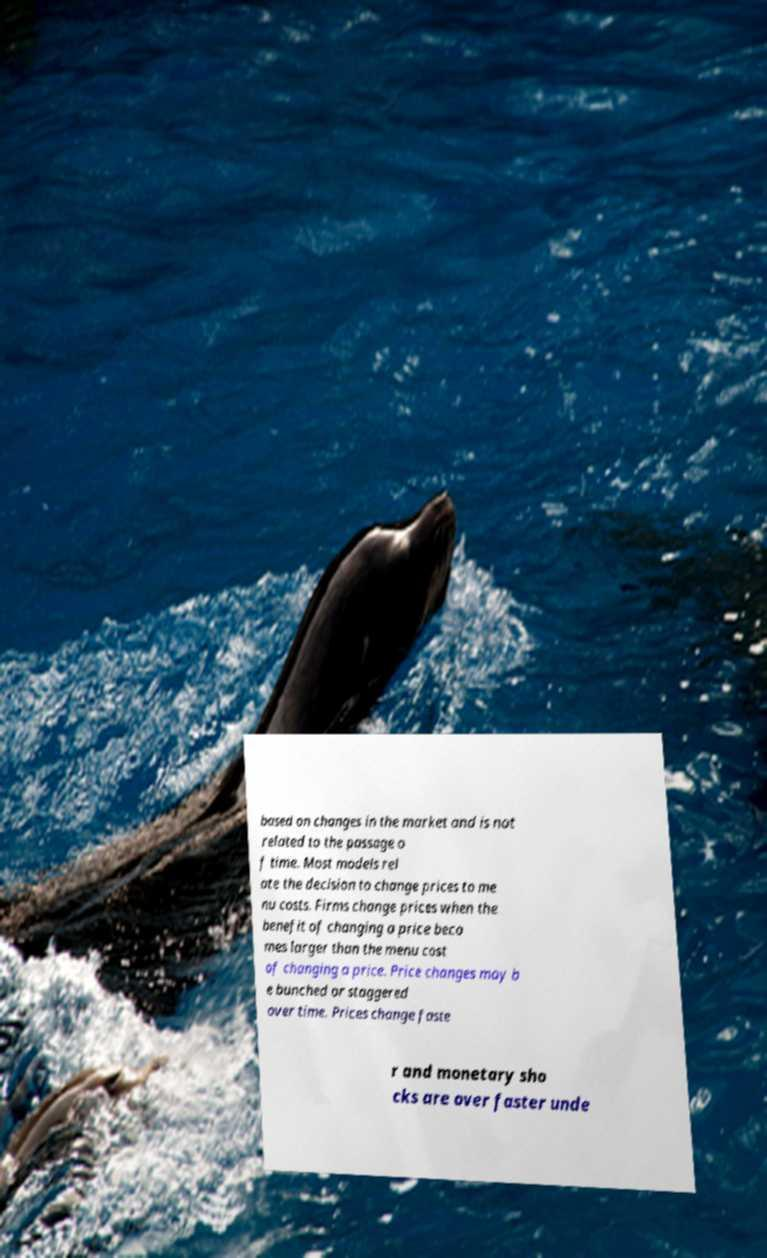There's text embedded in this image that I need extracted. Can you transcribe it verbatim? based on changes in the market and is not related to the passage o f time. Most models rel ate the decision to change prices to me nu costs. Firms change prices when the benefit of changing a price beco mes larger than the menu cost of changing a price. Price changes may b e bunched or staggered over time. Prices change faste r and monetary sho cks are over faster unde 